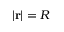<formula> <loc_0><loc_0><loc_500><loc_500>| r | = R</formula> 